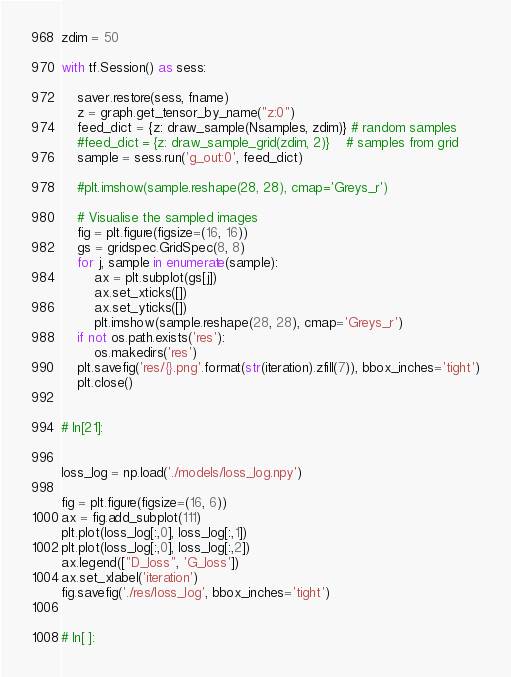Convert code to text. <code><loc_0><loc_0><loc_500><loc_500><_Python_>zdim = 50

with tf.Session() as sess:    
    
    saver.restore(sess, fname)
    z = graph.get_tensor_by_name("z:0")
    feed_dict = {z: draw_sample(Nsamples, zdim)} # random samples    
    #feed_dict = {z: draw_sample_grid(zdim, 2)}    # samples from grid
    sample = sess.run('g_out:0', feed_dict)
    
    #plt.imshow(sample.reshape(28, 28), cmap='Greys_r')
    
    # Visualise the sampled images
    fig = plt.figure(figsize=(16, 16))
    gs = gridspec.GridSpec(8, 8)
    for j, sample in enumerate(sample):
        ax = plt.subplot(gs[j])
        ax.set_xticks([])
        ax.set_yticks([])
        plt.imshow(sample.reshape(28, 28), cmap='Greys_r')
    if not os.path.exists('res'):
        os.makedirs('res')
    plt.savefig('res/{}.png'.format(str(iteration).zfill(7)), bbox_inches='tight')
    plt.close()


# In[21]:


loss_log = np.load('./models/loss_log.npy')

fig = plt.figure(figsize=(16, 6))
ax = fig.add_subplot(111)
plt.plot(loss_log[:,0], loss_log[:,1])
plt.plot(loss_log[:,0], loss_log[:,2])
ax.legend(["D_loss", 'G_loss'])
ax.set_xlabel('iteration')
fig.savefig('./res/loss_log', bbox_inches='tight')


# In[ ]:




</code> 